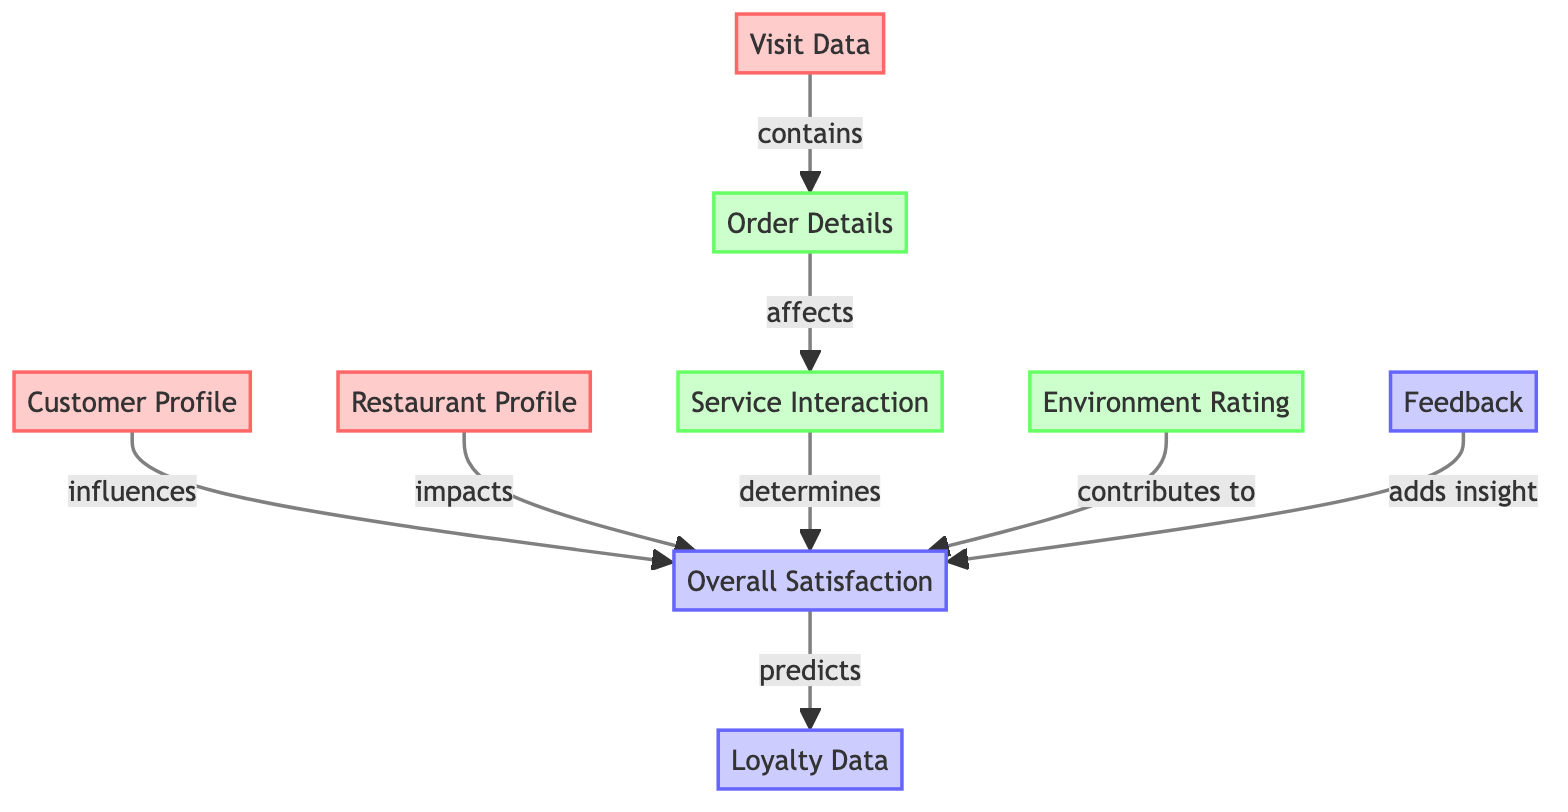What is the first input node in the diagram? The first input node in the diagram is "Customer Profile". It is the starting point of the flow and provides initial information that influences the overall satisfaction.
Answer: Customer Profile How many output nodes are there? There are three output nodes in the diagram: "Overall Satisfaction", "Feedback", and "Loyalty Data". These nodes represent the outcomes of the system.
Answer: Three Which input node impacts overall satisfaction? The input node that impacts overall satisfaction is "Restaurant Profile". It is directly connected to the "Overall Satisfaction" node, indicating its influence.
Answer: Restaurant Profile What does the "Order Details" affect? The "Order Details" affects the "Service Interaction" node. This shows that the specifics of the order play a role in how service is experienced by customers.
Answer: Service Interaction How does "Environment Rating" contribute to customer satisfaction? "Environment Rating" contributes to customer satisfaction by directly linking to the "Overall Satisfaction" node, suggesting that the environment in which a meal is enjoyed plays a significant role in satisfaction levels.
Answer: Contributes to Overall Satisfaction What is the relationship between "Feedback" and overall satisfaction? "Feedback" adds insight to the "Overall Satisfaction". This indicates that customer feedback plays a vital role in understanding and improving satisfaction levels in restaurants.
Answer: Adds insight Which node predicts loyalty data? The node that predicts loyalty data is the "Overall Satisfaction" node. It processes the input information to provide insights on customer loyalty.
Answer: Overall Satisfaction What is the connection between "Visit Data" and "Service Interaction"? "Visit Data" contains "Order Details", which in turn affects "Service Interaction", creating a chain that illustrates how visit specifics influence service experiences.
Answer: Contains and affects 